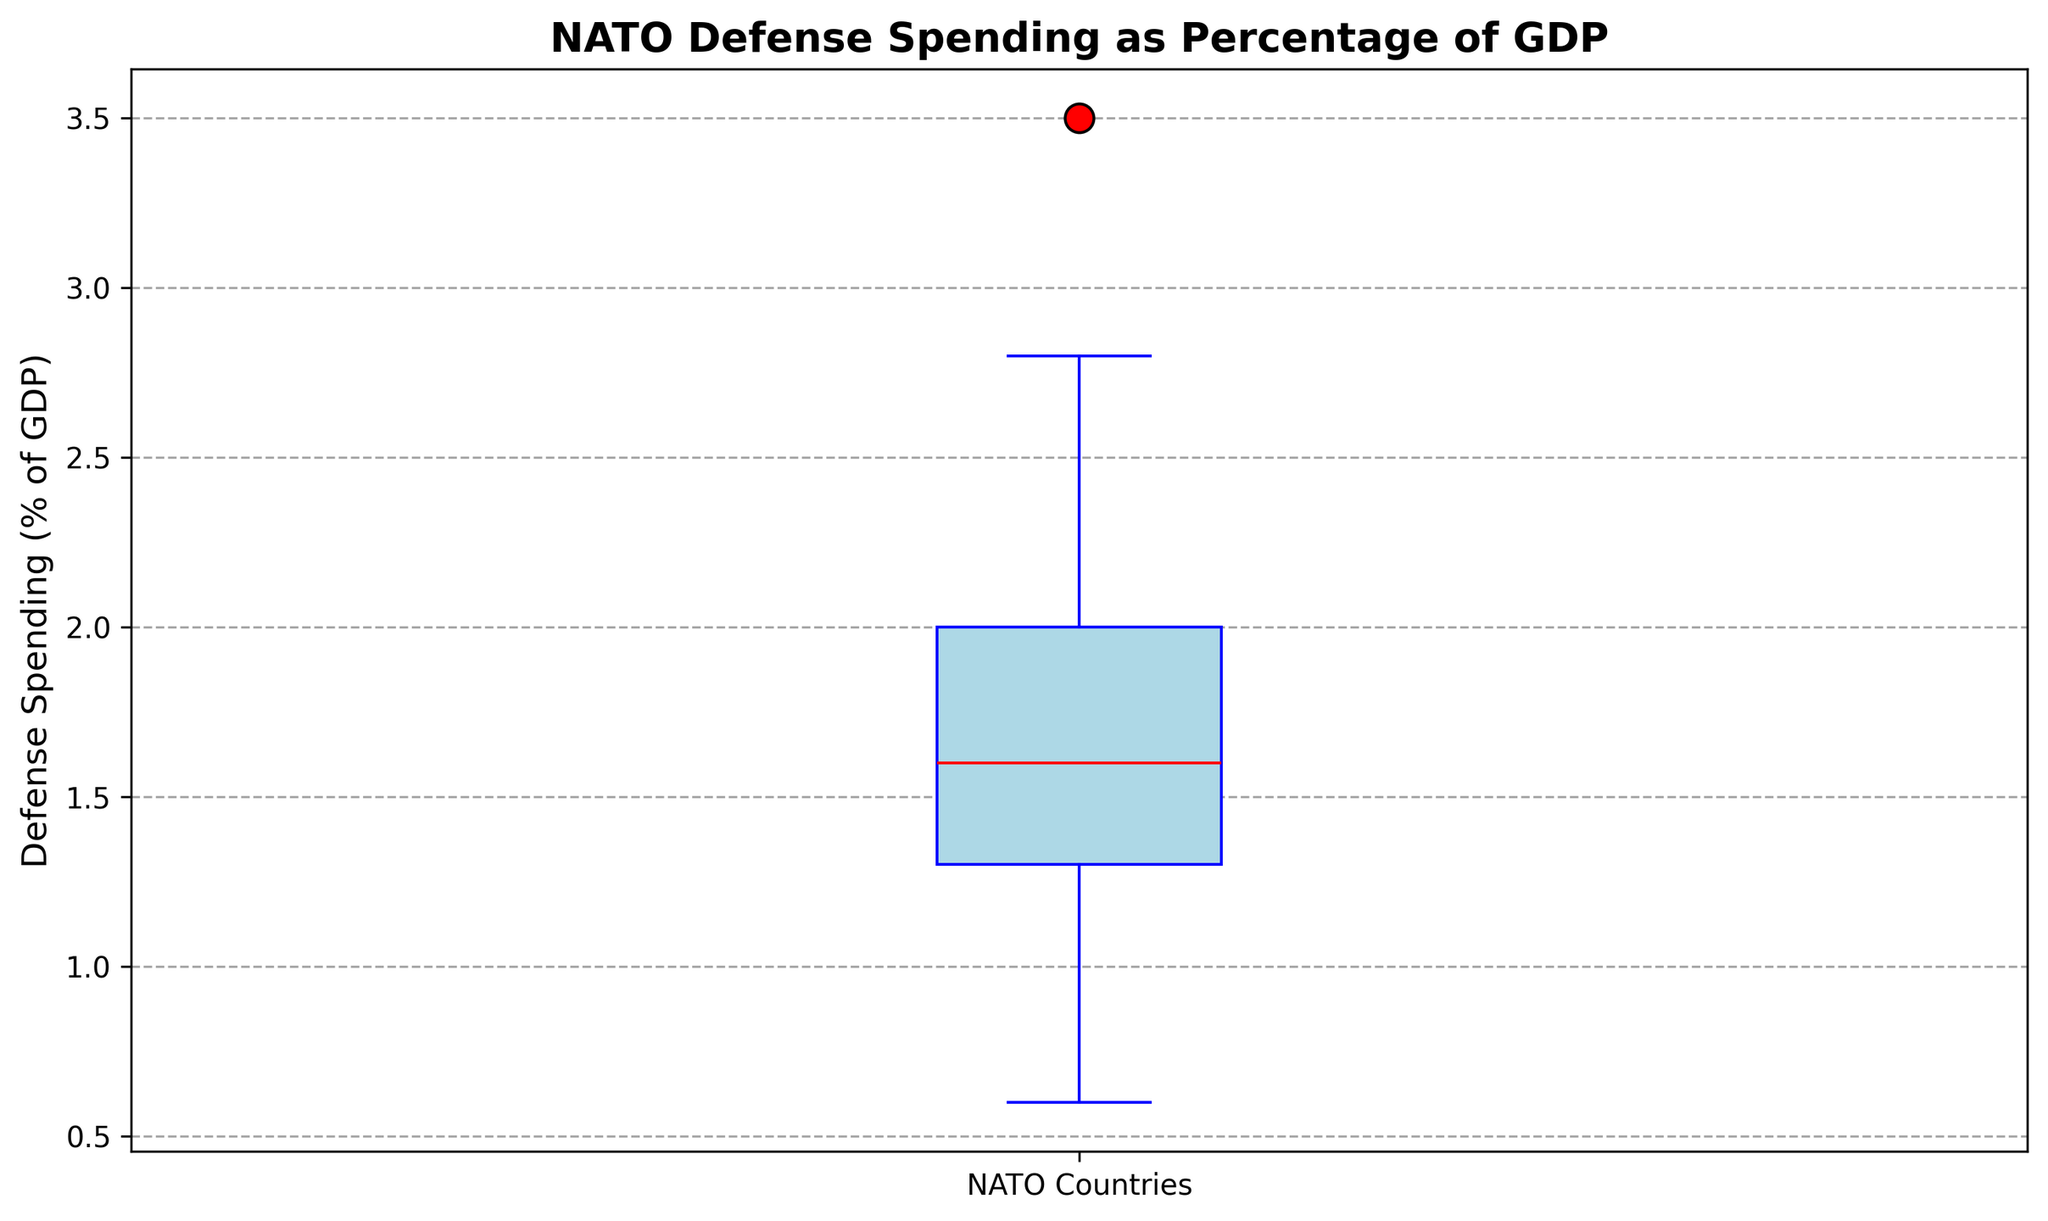What is the median value of NATO countries' defense spending as a percentage of GDP? The median value is the middle value of the dataset when arranged in ascending order. In the box plot, the median is marked by a red line within the box.
Answer: 1.6 Which country has the highest defense spending as a percentage of GDP, based on the given data? The highest value can be observed from the upper whisker of the box plot. According to the box plot, the upper whisker reaches approximately 3.5%. The United States has this value.
Answer: United States What is the range of defense spending as a percentage of GDP among NATO countries? The range is calculated by the difference between the maximum and minimum values. In the box plot, the maximum value (upper whisker) is around 3.5% and the minimum value (lower whisker) is around 0.6%. So, the range is 3.5% - 0.6%.
Answer: 2.9 How many NATO countries have defense spending greater than the upper quartile value (approximately)? The upper quartile value (75th percentile) is the top edge of the box in the box plot. To answer this, we need to count the individual data points (outliers) above this value. There are 3 outlier points observed above the box.
Answer: 3 What is interquartile range (IQR) of the defense spending data? The IQR is the difference between the upper quartile (75th percentile) value and the lower quartile (25th percentile) value. From the box plot, the upper quartile is around 2.0% and the lower quartile is around 1.4%. So, IQR = 2.0% - 1.4%.
Answer: 0.6 Which defense spending value appears to be an outlier on the lower end of the box plot? Outliers on the lower end are the data points below the lower whisker. In the box plot, there is one visible point below the lower whisker, corresponding to approximately 0.6%.
Answer: 0.6 How does the median value compare to the upper quartile value? The median value is the midpoint value marked by a red line, and the upper quartile is the top edge of the box. The median (1.6%) is less than the upper quartile (2.0%).
Answer: less than What can you infer about the density of the data points in the lower quartile region relative to the list's upper quartile region? The density of data points can be inferred by the length of the sections of the box. A longer box section indicates a wider spread of data points. The lower quartile region (between 1.4% and 1.6%) is shorter compared to the upper quartile region (between 1.6% and 2.0%), suggesting less density of data points in the lower quartile region.
Answer: less dense in lower quartile 